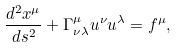Convert formula to latex. <formula><loc_0><loc_0><loc_500><loc_500>\frac { d ^ { 2 } x ^ { \mu } } { d s ^ { 2 } } + \Gamma _ { \nu \lambda } ^ { \mu } u ^ { \nu } u ^ { \lambda } = f ^ { \mu } ,</formula> 